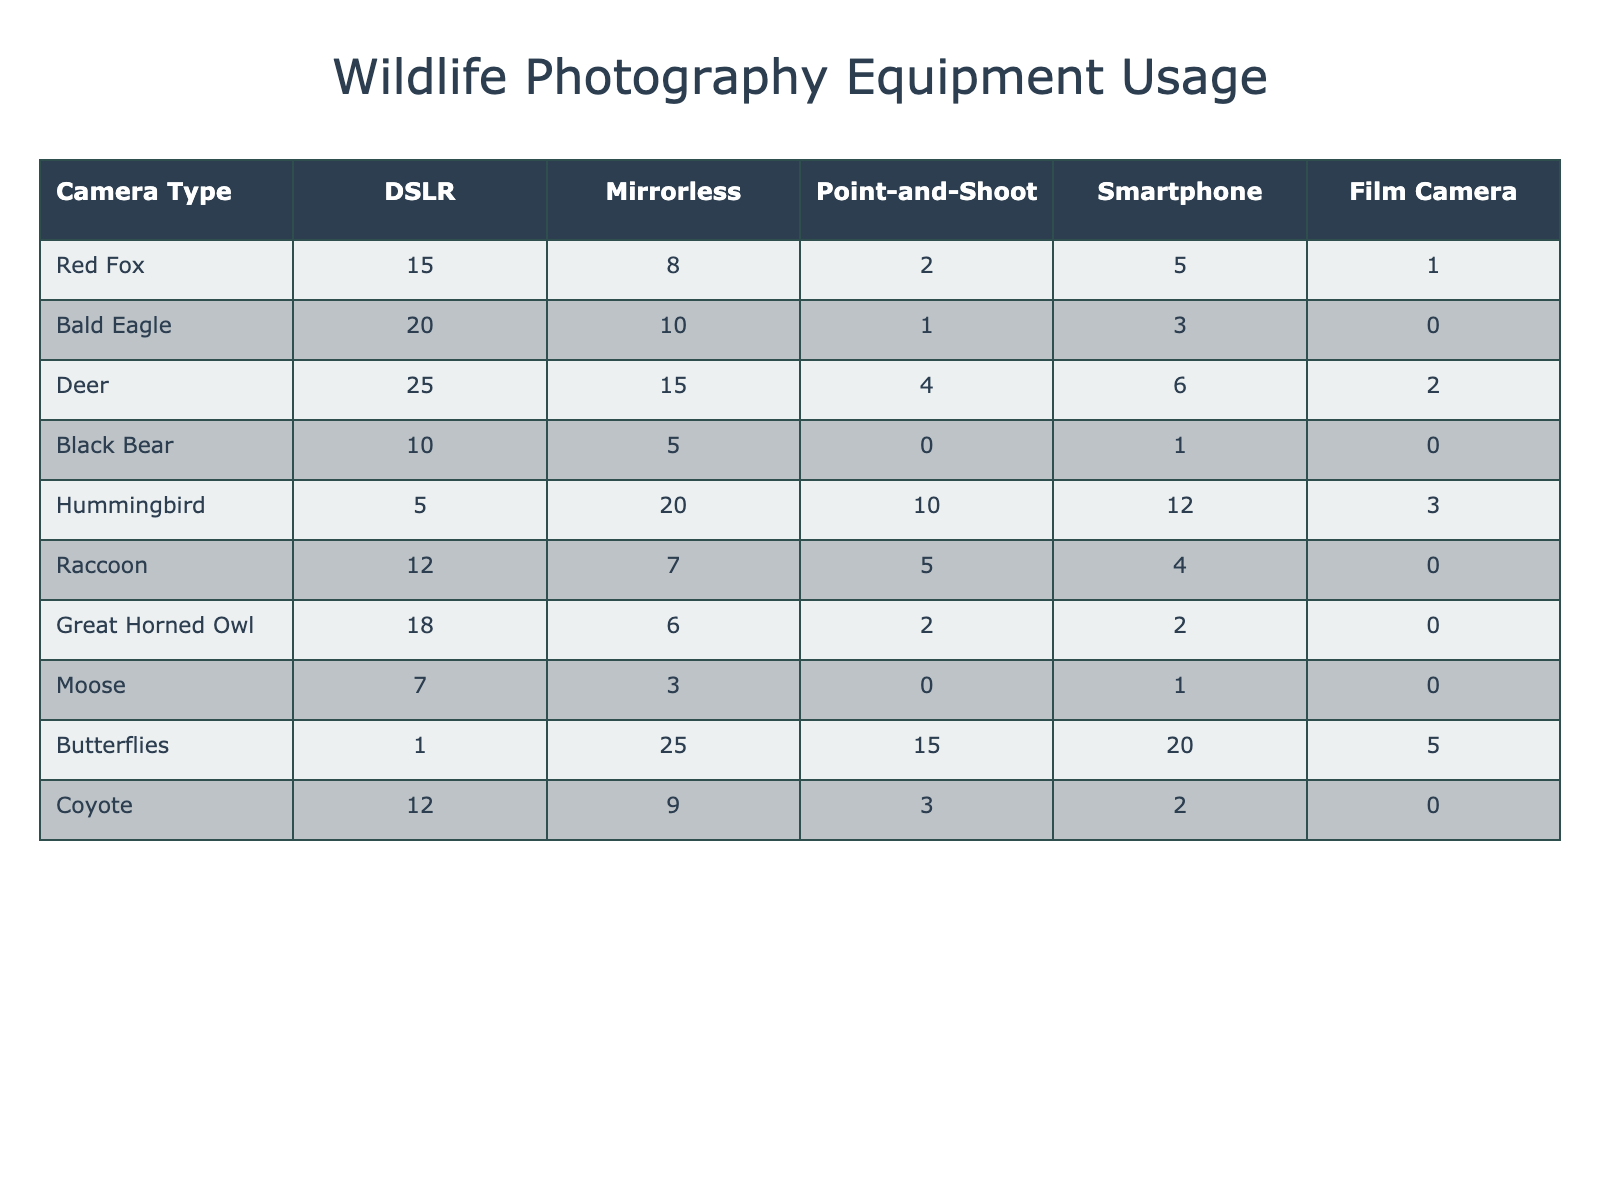What is the most photographed wildlife type using a DSLR? By looking at the DSLR column, the highest value is 25, which corresponds to Deer. Therefore, Deer is the most photographed wildlife type with that camera.
Answer: Deer How many Bald Eagles were photographed using a smartphone? Referring to the smartphone column for Bald Eagle, the value is 3. Thus, 3 Bald Eagles were photographed using a smartphone.
Answer: 3 Which wildlife type has the highest total number of photographs taken across all equipment? To find the total photographs for each wildlife type, I will sum the values in each row: Red Fox (31), Bald Eagle (34), Deer (52), Black Bear (16), Hummingbird (50), Raccoon (28), Great Horned Owl (28), Moose (11), Butterflies (66), and Coyote (26). Butterflies have the highest total at 66.
Answer: Butterflies Is the number of photographs taken of Hummingbirds using a Mirrorless camera greater than those taken with a DSLR? The value for Hummingbirds using Mirrorless is 20, and using DSLR is 5. Since 20 is greater than 5, this statement is true.
Answer: Yes What is the average number of photographs taken of Deer and Black Bear combined using a Point-and-Shoot camera? The values for Deer and Black Bear using Point-and-Shoot cameras are 4 and 0 respectively. The total is 4 + 0 = 4. The average is 4/2 = 2.
Answer: 2 How many more Red Fox photographs were taken with a DSLR than with a Film Camera? The number of photographs of Red Fox with DSLR is 15, while with Film Camera it is 1. The difference is 15 - 1 = 14.
Answer: 14 Does the total number of photographs taken of Raccoons exceed those of Mooses across all equipment? The total for Raccoons is 28 (12 + 7 + 5 + 4 + 0) and for Mooses is 11 (7 + 3 + 0 + 1 + 0). Since 28 is greater than 11, this statement is true.
Answer: Yes What is the combined total for Hummingbird photography using a Point-and-Shoot and a Smartphone? The values for Hummingbird with Point-and-Shoot is 10, and with Smartphone is 12. Combined they add up to 10 + 12 = 22.
Answer: 22 